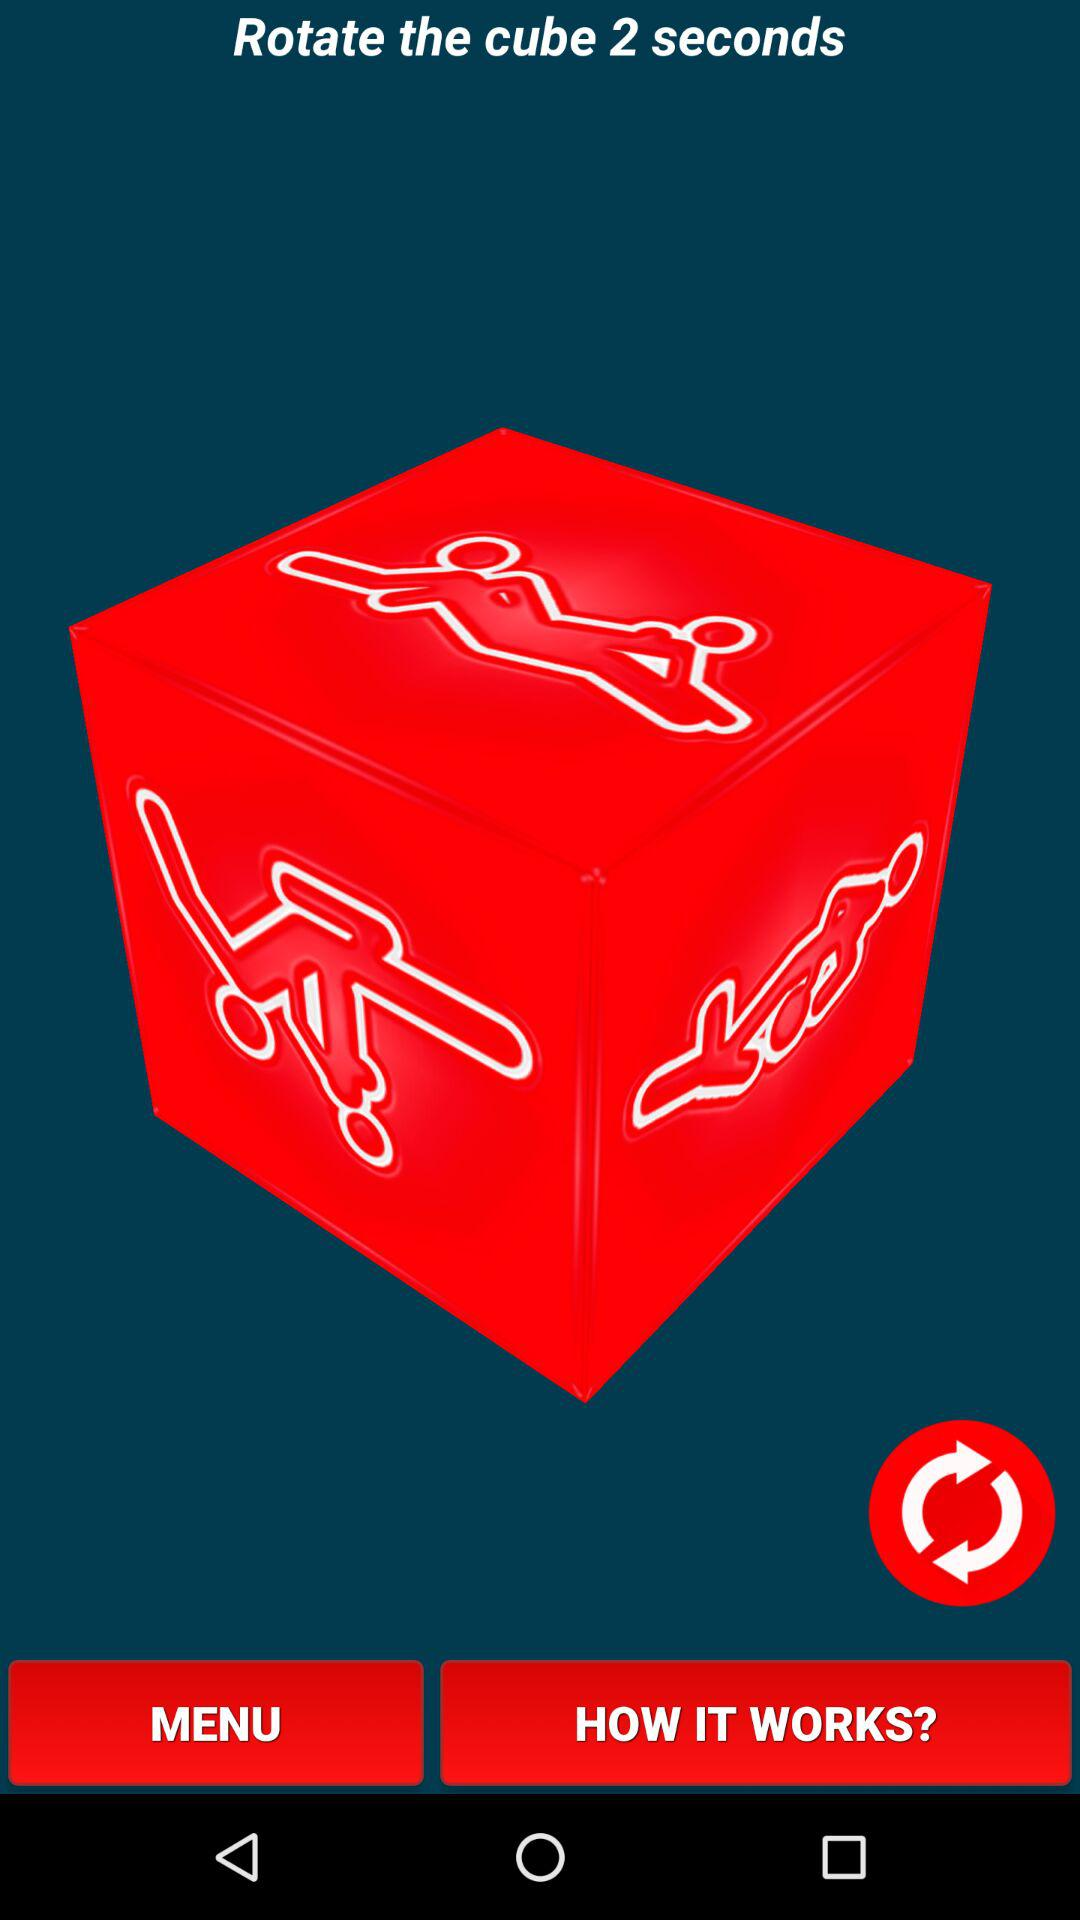How many more seconds do you have to wait until the cube rotates?
Answer the question using a single word or phrase. 2 